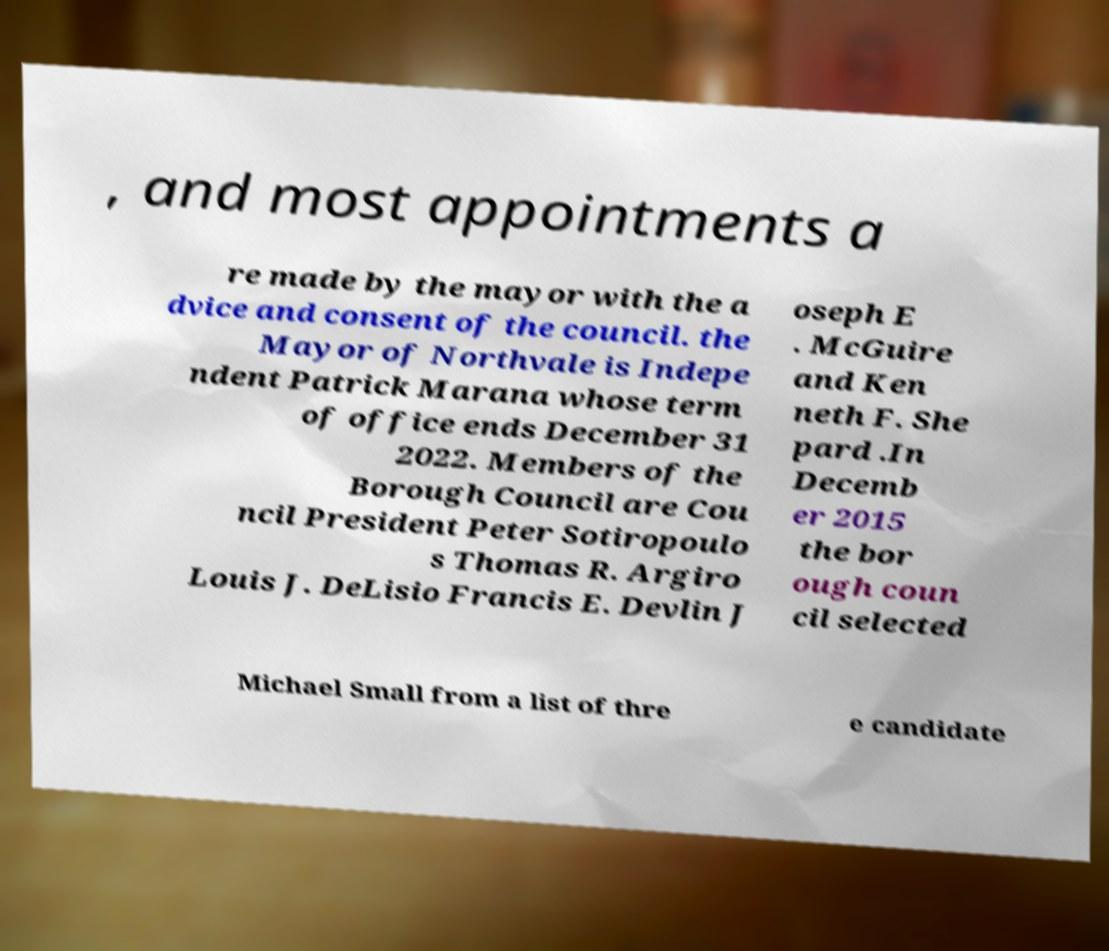Please read and relay the text visible in this image. What does it say? , and most appointments a re made by the mayor with the a dvice and consent of the council. the Mayor of Northvale is Indepe ndent Patrick Marana whose term of office ends December 31 2022. Members of the Borough Council are Cou ncil President Peter Sotiropoulo s Thomas R. Argiro Louis J. DeLisio Francis E. Devlin J oseph E . McGuire and Ken neth F. She pard .In Decemb er 2015 the bor ough coun cil selected Michael Small from a list of thre e candidate 